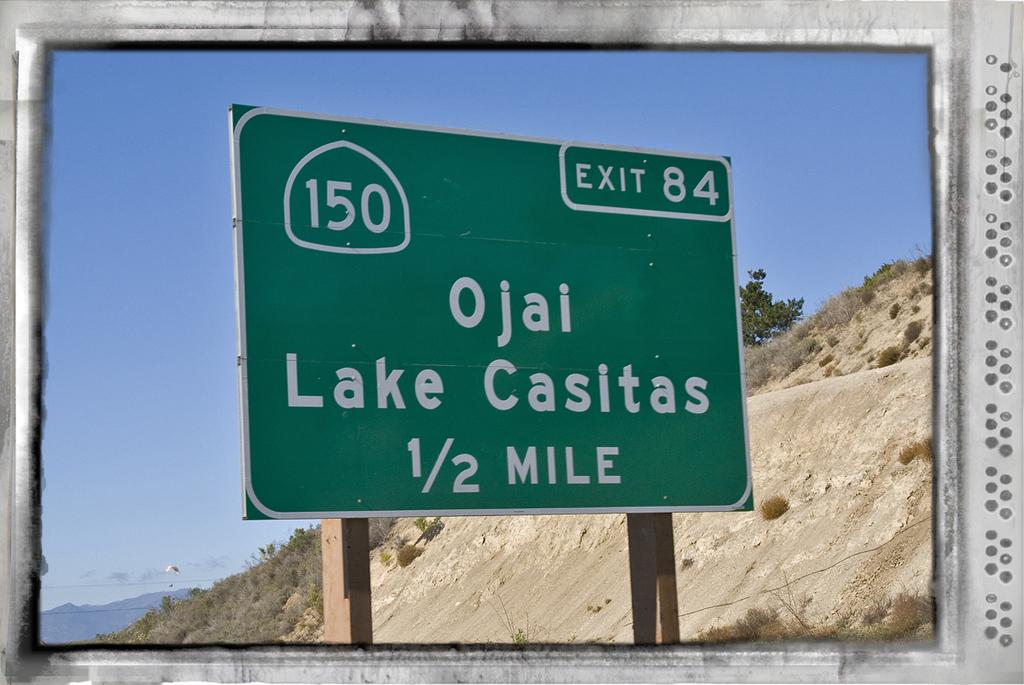<image>
Provide a brief description of the given image. A directional street sign for Ojai Lake Casitas 